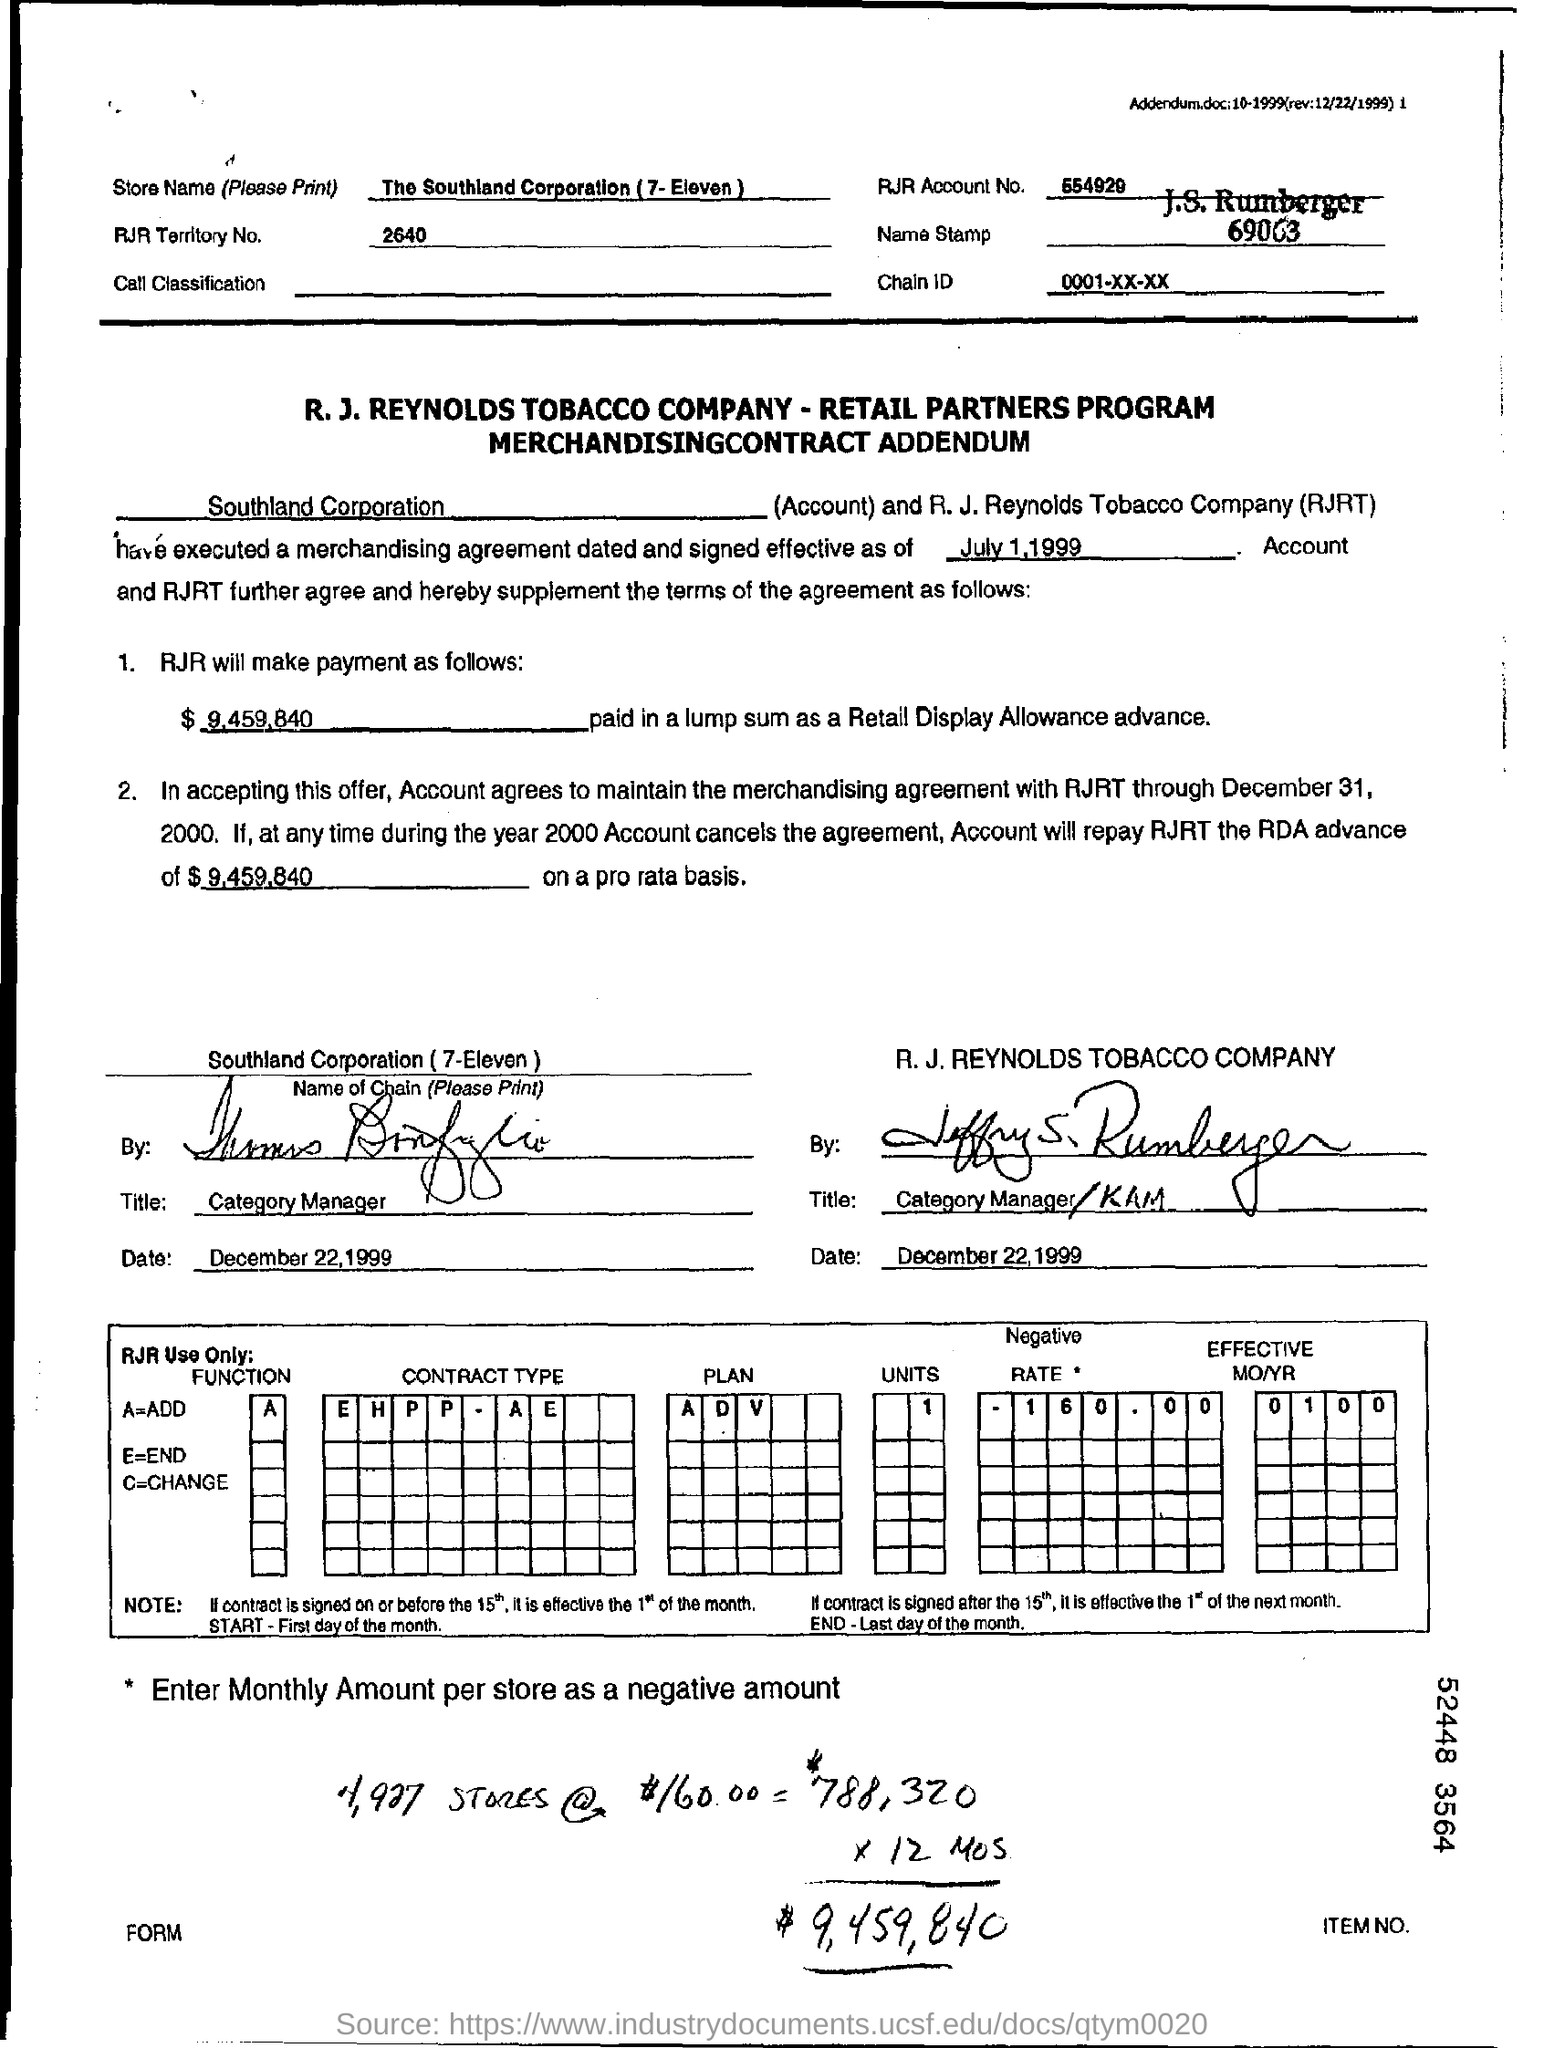List a handful of essential elements in this visual. RJR will pay a lump sum of $9,459,840 as a retail display allowance advance. A equals the result of adding. The RJR account number is 554929. The store name is The Southland Corporation (7-Eleven). The chain ID mentioned in the form is 0001-XX-XX... 